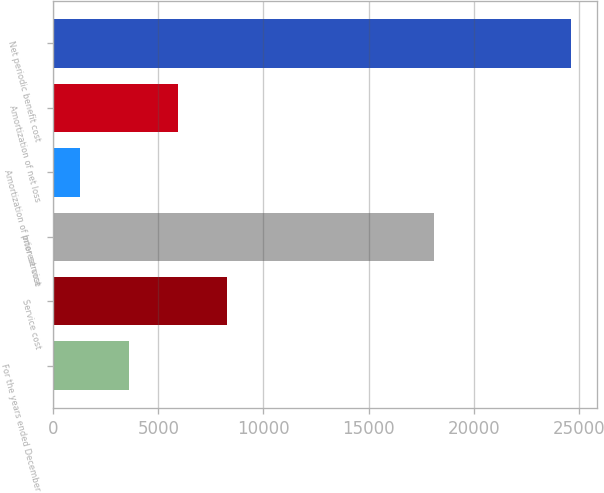Convert chart. <chart><loc_0><loc_0><loc_500><loc_500><bar_chart><fcel>For the years ended December<fcel>Service cost<fcel>Interest cost<fcel>Amortization of prior service<fcel>Amortization of net loss<fcel>Net periodic benefit cost<nl><fcel>3613.5<fcel>8282.5<fcel>18115<fcel>1279<fcel>5948<fcel>24624<nl></chart> 